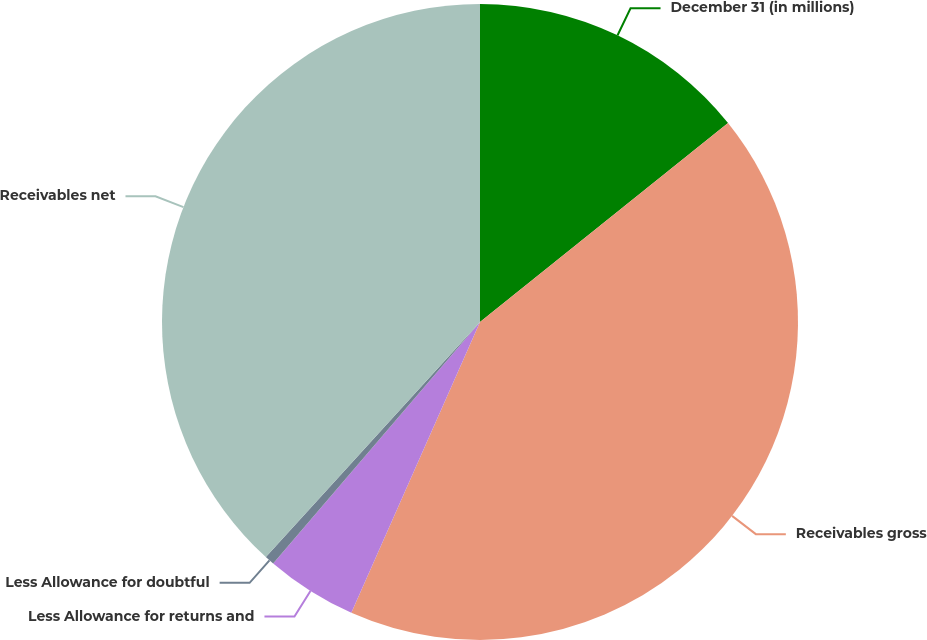Convert chart to OTSL. <chart><loc_0><loc_0><loc_500><loc_500><pie_chart><fcel>December 31 (in millions)<fcel>Receivables gross<fcel>Less Allowance for returns and<fcel>Less Allowance for doubtful<fcel>Receivables net<nl><fcel>14.24%<fcel>42.39%<fcel>4.64%<fcel>0.49%<fcel>38.24%<nl></chart> 